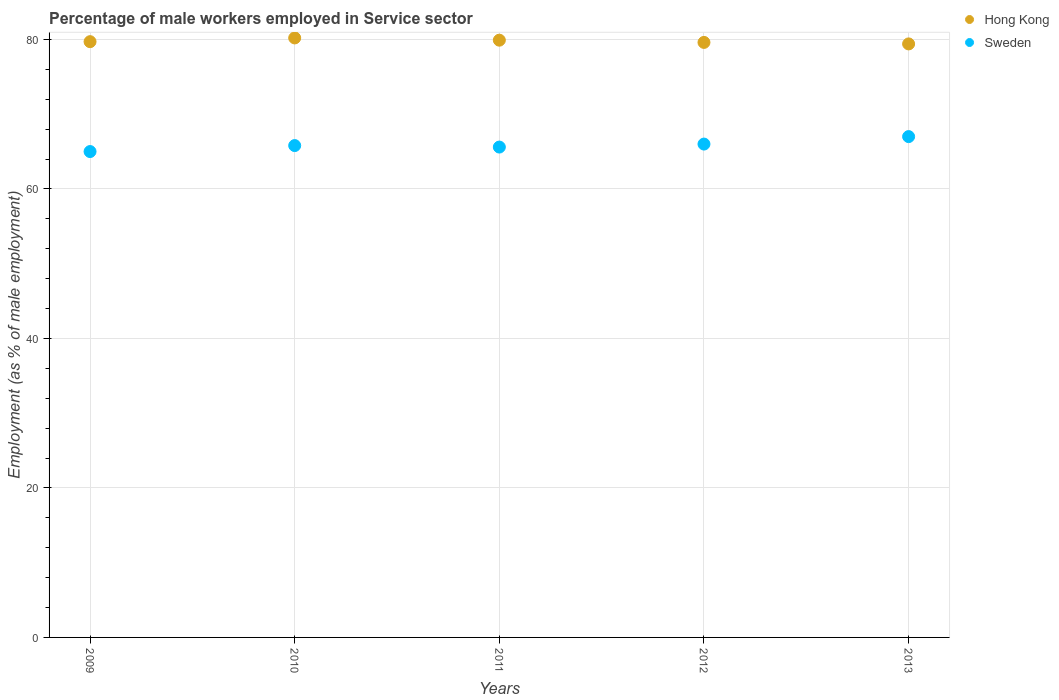How many different coloured dotlines are there?
Ensure brevity in your answer.  2. Across all years, what is the maximum percentage of male workers employed in Service sector in Hong Kong?
Your answer should be compact. 80.2. In which year was the percentage of male workers employed in Service sector in Hong Kong maximum?
Make the answer very short. 2010. What is the total percentage of male workers employed in Service sector in Sweden in the graph?
Ensure brevity in your answer.  329.4. What is the difference between the percentage of male workers employed in Service sector in Hong Kong in 2009 and that in 2011?
Ensure brevity in your answer.  -0.2. What is the difference between the percentage of male workers employed in Service sector in Hong Kong in 2011 and the percentage of male workers employed in Service sector in Sweden in 2009?
Offer a very short reply. 14.9. What is the average percentage of male workers employed in Service sector in Sweden per year?
Make the answer very short. 65.88. In the year 2012, what is the difference between the percentage of male workers employed in Service sector in Sweden and percentage of male workers employed in Service sector in Hong Kong?
Give a very brief answer. -13.6. In how many years, is the percentage of male workers employed in Service sector in Hong Kong greater than 52 %?
Your response must be concise. 5. What is the ratio of the percentage of male workers employed in Service sector in Sweden in 2009 to that in 2012?
Provide a short and direct response. 0.98. Is the difference between the percentage of male workers employed in Service sector in Sweden in 2011 and 2012 greater than the difference between the percentage of male workers employed in Service sector in Hong Kong in 2011 and 2012?
Your answer should be very brief. No. What is the difference between the highest and the second highest percentage of male workers employed in Service sector in Hong Kong?
Your answer should be very brief. 0.3. What is the difference between the highest and the lowest percentage of male workers employed in Service sector in Hong Kong?
Your answer should be very brief. 0.8. Is the sum of the percentage of male workers employed in Service sector in Hong Kong in 2011 and 2012 greater than the maximum percentage of male workers employed in Service sector in Sweden across all years?
Keep it short and to the point. Yes. Is the percentage of male workers employed in Service sector in Sweden strictly greater than the percentage of male workers employed in Service sector in Hong Kong over the years?
Ensure brevity in your answer.  No. Is the percentage of male workers employed in Service sector in Hong Kong strictly less than the percentage of male workers employed in Service sector in Sweden over the years?
Your answer should be very brief. No. How many dotlines are there?
Your answer should be very brief. 2. How many years are there in the graph?
Provide a short and direct response. 5. What is the difference between two consecutive major ticks on the Y-axis?
Provide a short and direct response. 20. Are the values on the major ticks of Y-axis written in scientific E-notation?
Your answer should be compact. No. Does the graph contain any zero values?
Provide a succinct answer. No. Does the graph contain grids?
Your answer should be compact. Yes. Where does the legend appear in the graph?
Make the answer very short. Top right. How are the legend labels stacked?
Offer a terse response. Vertical. What is the title of the graph?
Your answer should be very brief. Percentage of male workers employed in Service sector. Does "Tunisia" appear as one of the legend labels in the graph?
Offer a very short reply. No. What is the label or title of the X-axis?
Give a very brief answer. Years. What is the label or title of the Y-axis?
Your response must be concise. Employment (as % of male employment). What is the Employment (as % of male employment) in Hong Kong in 2009?
Make the answer very short. 79.7. What is the Employment (as % of male employment) in Sweden in 2009?
Give a very brief answer. 65. What is the Employment (as % of male employment) of Hong Kong in 2010?
Keep it short and to the point. 80.2. What is the Employment (as % of male employment) of Sweden in 2010?
Give a very brief answer. 65.8. What is the Employment (as % of male employment) of Hong Kong in 2011?
Your answer should be very brief. 79.9. What is the Employment (as % of male employment) of Sweden in 2011?
Give a very brief answer. 65.6. What is the Employment (as % of male employment) in Hong Kong in 2012?
Your answer should be very brief. 79.6. What is the Employment (as % of male employment) in Sweden in 2012?
Make the answer very short. 66. What is the Employment (as % of male employment) in Hong Kong in 2013?
Offer a very short reply. 79.4. Across all years, what is the maximum Employment (as % of male employment) of Hong Kong?
Your answer should be compact. 80.2. Across all years, what is the minimum Employment (as % of male employment) in Hong Kong?
Give a very brief answer. 79.4. What is the total Employment (as % of male employment) in Hong Kong in the graph?
Ensure brevity in your answer.  398.8. What is the total Employment (as % of male employment) in Sweden in the graph?
Provide a succinct answer. 329.4. What is the difference between the Employment (as % of male employment) in Hong Kong in 2009 and that in 2010?
Your response must be concise. -0.5. What is the difference between the Employment (as % of male employment) of Sweden in 2009 and that in 2010?
Make the answer very short. -0.8. What is the difference between the Employment (as % of male employment) in Hong Kong in 2009 and that in 2011?
Provide a short and direct response. -0.2. What is the difference between the Employment (as % of male employment) of Hong Kong in 2009 and that in 2012?
Your answer should be very brief. 0.1. What is the difference between the Employment (as % of male employment) in Sweden in 2009 and that in 2012?
Your answer should be very brief. -1. What is the difference between the Employment (as % of male employment) in Sweden in 2009 and that in 2013?
Your response must be concise. -2. What is the difference between the Employment (as % of male employment) in Hong Kong in 2010 and that in 2011?
Your response must be concise. 0.3. What is the difference between the Employment (as % of male employment) in Sweden in 2010 and that in 2011?
Provide a short and direct response. 0.2. What is the difference between the Employment (as % of male employment) of Hong Kong in 2010 and that in 2012?
Your answer should be compact. 0.6. What is the difference between the Employment (as % of male employment) in Sweden in 2010 and that in 2012?
Your answer should be very brief. -0.2. What is the difference between the Employment (as % of male employment) of Sweden in 2011 and that in 2012?
Your answer should be compact. -0.4. What is the difference between the Employment (as % of male employment) of Sweden in 2011 and that in 2013?
Keep it short and to the point. -1.4. What is the difference between the Employment (as % of male employment) in Hong Kong in 2009 and the Employment (as % of male employment) in Sweden in 2012?
Keep it short and to the point. 13.7. What is the difference between the Employment (as % of male employment) of Hong Kong in 2009 and the Employment (as % of male employment) of Sweden in 2013?
Provide a short and direct response. 12.7. What is the difference between the Employment (as % of male employment) in Hong Kong in 2010 and the Employment (as % of male employment) in Sweden in 2012?
Provide a succinct answer. 14.2. What is the difference between the Employment (as % of male employment) of Hong Kong in 2010 and the Employment (as % of male employment) of Sweden in 2013?
Provide a short and direct response. 13.2. What is the difference between the Employment (as % of male employment) of Hong Kong in 2011 and the Employment (as % of male employment) of Sweden in 2012?
Give a very brief answer. 13.9. What is the difference between the Employment (as % of male employment) in Hong Kong in 2011 and the Employment (as % of male employment) in Sweden in 2013?
Offer a very short reply. 12.9. What is the difference between the Employment (as % of male employment) in Hong Kong in 2012 and the Employment (as % of male employment) in Sweden in 2013?
Give a very brief answer. 12.6. What is the average Employment (as % of male employment) of Hong Kong per year?
Make the answer very short. 79.76. What is the average Employment (as % of male employment) in Sweden per year?
Your answer should be very brief. 65.88. In the year 2011, what is the difference between the Employment (as % of male employment) of Hong Kong and Employment (as % of male employment) of Sweden?
Your answer should be compact. 14.3. In the year 2012, what is the difference between the Employment (as % of male employment) in Hong Kong and Employment (as % of male employment) in Sweden?
Offer a terse response. 13.6. In the year 2013, what is the difference between the Employment (as % of male employment) of Hong Kong and Employment (as % of male employment) of Sweden?
Give a very brief answer. 12.4. What is the ratio of the Employment (as % of male employment) of Hong Kong in 2009 to that in 2010?
Ensure brevity in your answer.  0.99. What is the ratio of the Employment (as % of male employment) in Sweden in 2009 to that in 2011?
Make the answer very short. 0.99. What is the ratio of the Employment (as % of male employment) of Sweden in 2009 to that in 2012?
Offer a terse response. 0.98. What is the ratio of the Employment (as % of male employment) in Sweden in 2009 to that in 2013?
Your answer should be compact. 0.97. What is the ratio of the Employment (as % of male employment) in Sweden in 2010 to that in 2011?
Provide a short and direct response. 1. What is the ratio of the Employment (as % of male employment) of Hong Kong in 2010 to that in 2012?
Keep it short and to the point. 1.01. What is the ratio of the Employment (as % of male employment) of Sweden in 2010 to that in 2013?
Ensure brevity in your answer.  0.98. What is the ratio of the Employment (as % of male employment) in Hong Kong in 2011 to that in 2013?
Offer a very short reply. 1.01. What is the ratio of the Employment (as % of male employment) in Sweden in 2011 to that in 2013?
Provide a succinct answer. 0.98. What is the ratio of the Employment (as % of male employment) in Hong Kong in 2012 to that in 2013?
Provide a short and direct response. 1. What is the ratio of the Employment (as % of male employment) in Sweden in 2012 to that in 2013?
Give a very brief answer. 0.99. What is the difference between the highest and the second highest Employment (as % of male employment) in Hong Kong?
Keep it short and to the point. 0.3. What is the difference between the highest and the second highest Employment (as % of male employment) in Sweden?
Provide a short and direct response. 1. 